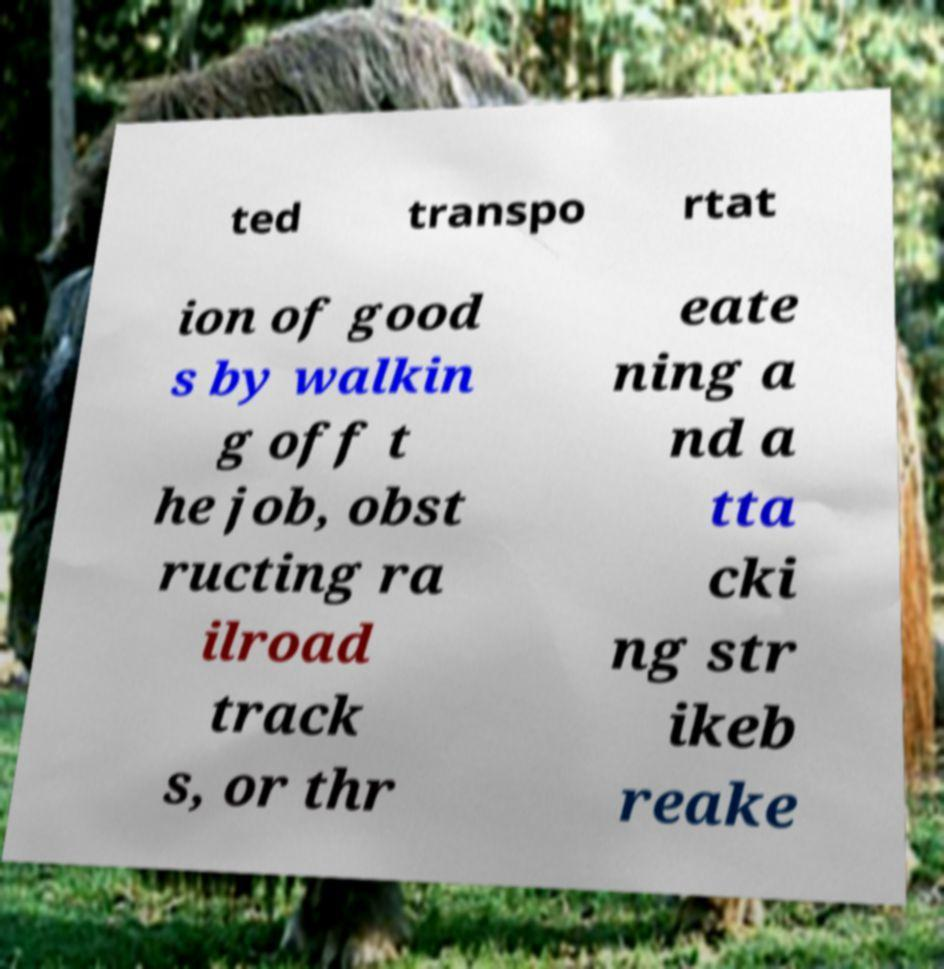Please read and relay the text visible in this image. What does it say? ted transpo rtat ion of good s by walkin g off t he job, obst ructing ra ilroad track s, or thr eate ning a nd a tta cki ng str ikeb reake 